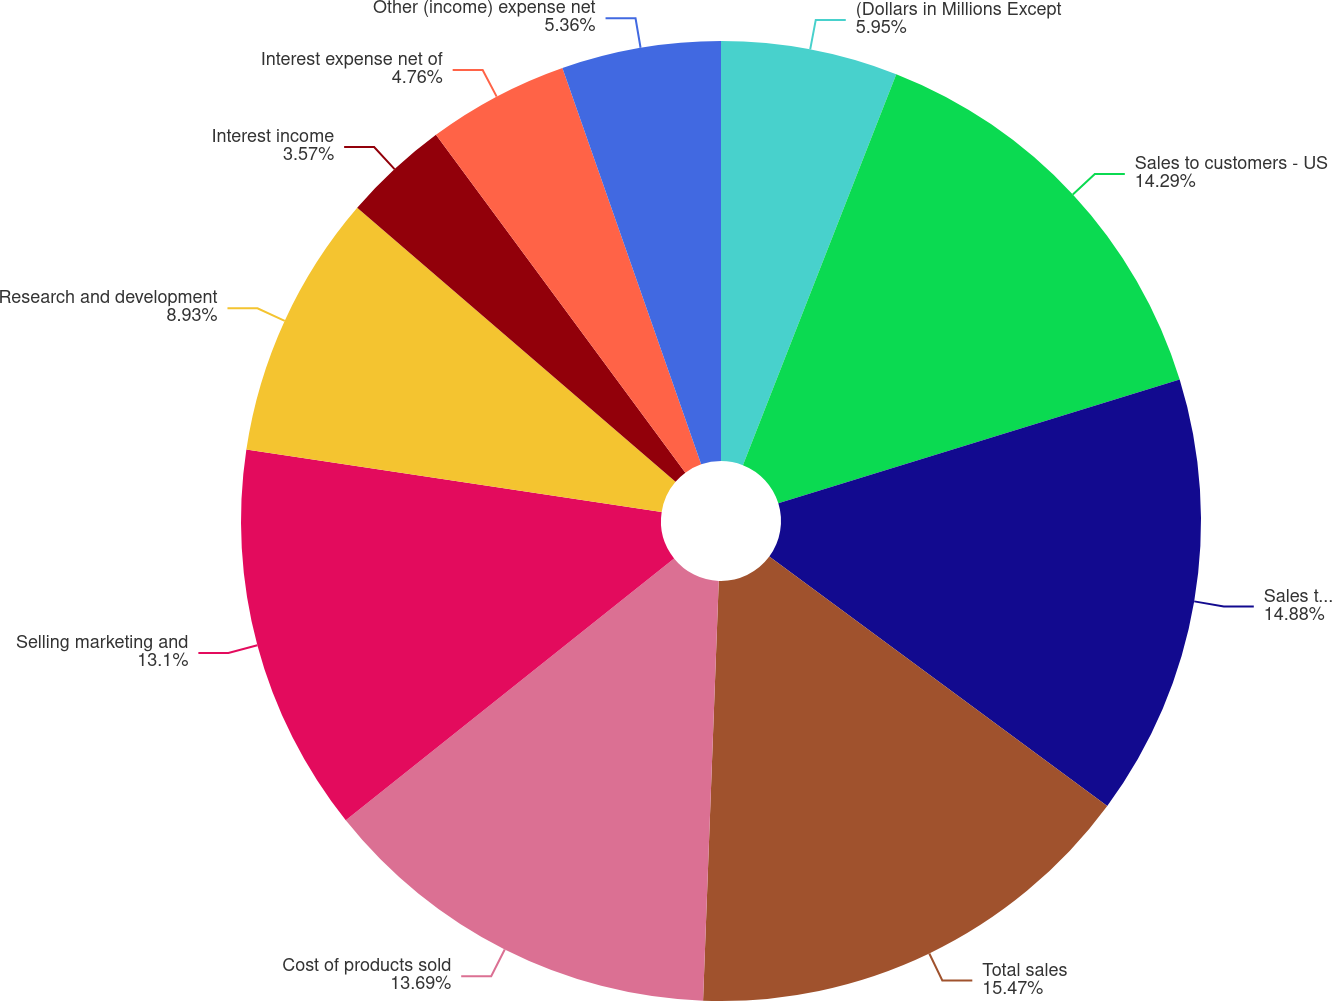Convert chart to OTSL. <chart><loc_0><loc_0><loc_500><loc_500><pie_chart><fcel>(Dollars in Millions Except<fcel>Sales to customers - US<fcel>Sales to customers -<fcel>Total sales<fcel>Cost of products sold<fcel>Selling marketing and<fcel>Research and development<fcel>Interest income<fcel>Interest expense net of<fcel>Other (income) expense net<nl><fcel>5.95%<fcel>14.29%<fcel>14.88%<fcel>15.48%<fcel>13.69%<fcel>13.1%<fcel>8.93%<fcel>3.57%<fcel>4.76%<fcel>5.36%<nl></chart> 